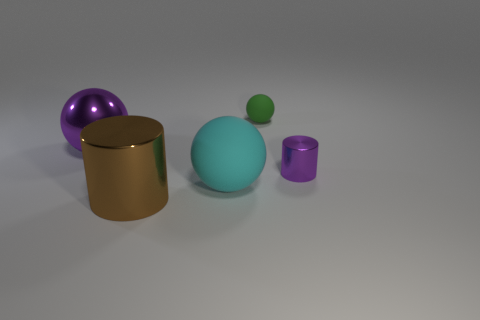What color is the large metal thing that is the same shape as the tiny metal object?
Your answer should be compact. Brown. What is the material of the small thing left of the purple metallic object on the right side of the large cyan rubber sphere?
Give a very brief answer. Rubber. Is the number of small things that are on the right side of the large cyan ball greater than the number of big purple spheres that are in front of the purple sphere?
Your response must be concise. Yes. What size is the cyan rubber thing?
Your response must be concise. Large. Do the thing left of the big brown cylinder and the tiny metal thing have the same color?
Your response must be concise. Yes. Are there any other things that are the same shape as the tiny matte thing?
Keep it short and to the point. Yes. There is a thing right of the small green ball; are there any cylinders to the left of it?
Make the answer very short. Yes. Are there fewer small purple metallic objects that are on the left side of the brown metal cylinder than big cyan things that are in front of the tiny rubber sphere?
Give a very brief answer. Yes. There is a rubber thing that is to the left of the sphere that is behind the thing that is to the left of the brown object; how big is it?
Give a very brief answer. Large. Is the size of the ball that is on the right side of the cyan sphere the same as the big cyan rubber sphere?
Keep it short and to the point. No. 